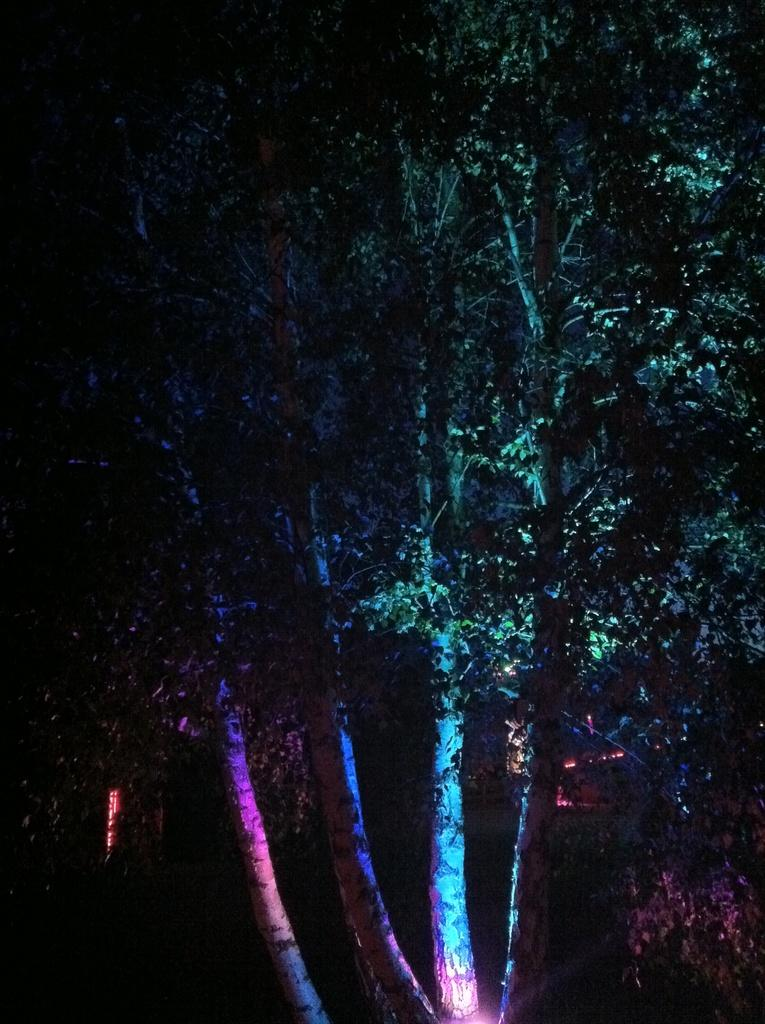What is the main object in the image? There is a tree in the image. Can you describe the lighting in the image? The image appears to be slightly dark. How many cattle can be seen grazing near the ocean in the image? There is no ocean or cattle present in the image; it only features a tree. What type of paint is used to create the image? The facts provided do not mention any information about the medium or paint used to create the image. 